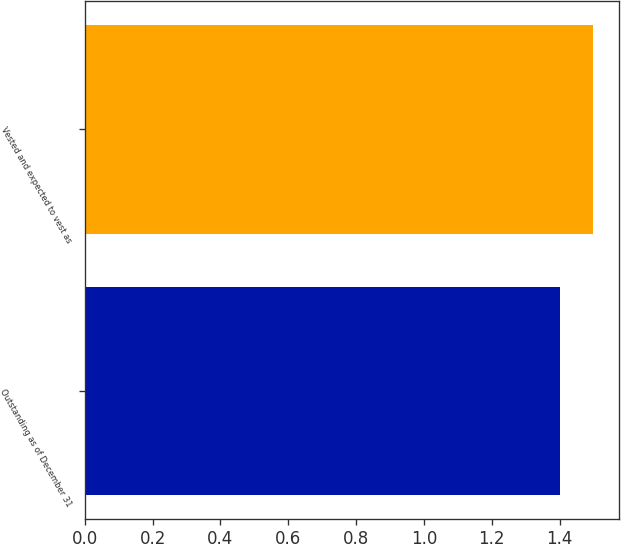Convert chart. <chart><loc_0><loc_0><loc_500><loc_500><bar_chart><fcel>Outstanding as of December 31<fcel>Vested and expected to vest as<nl><fcel>1.4<fcel>1.5<nl></chart> 